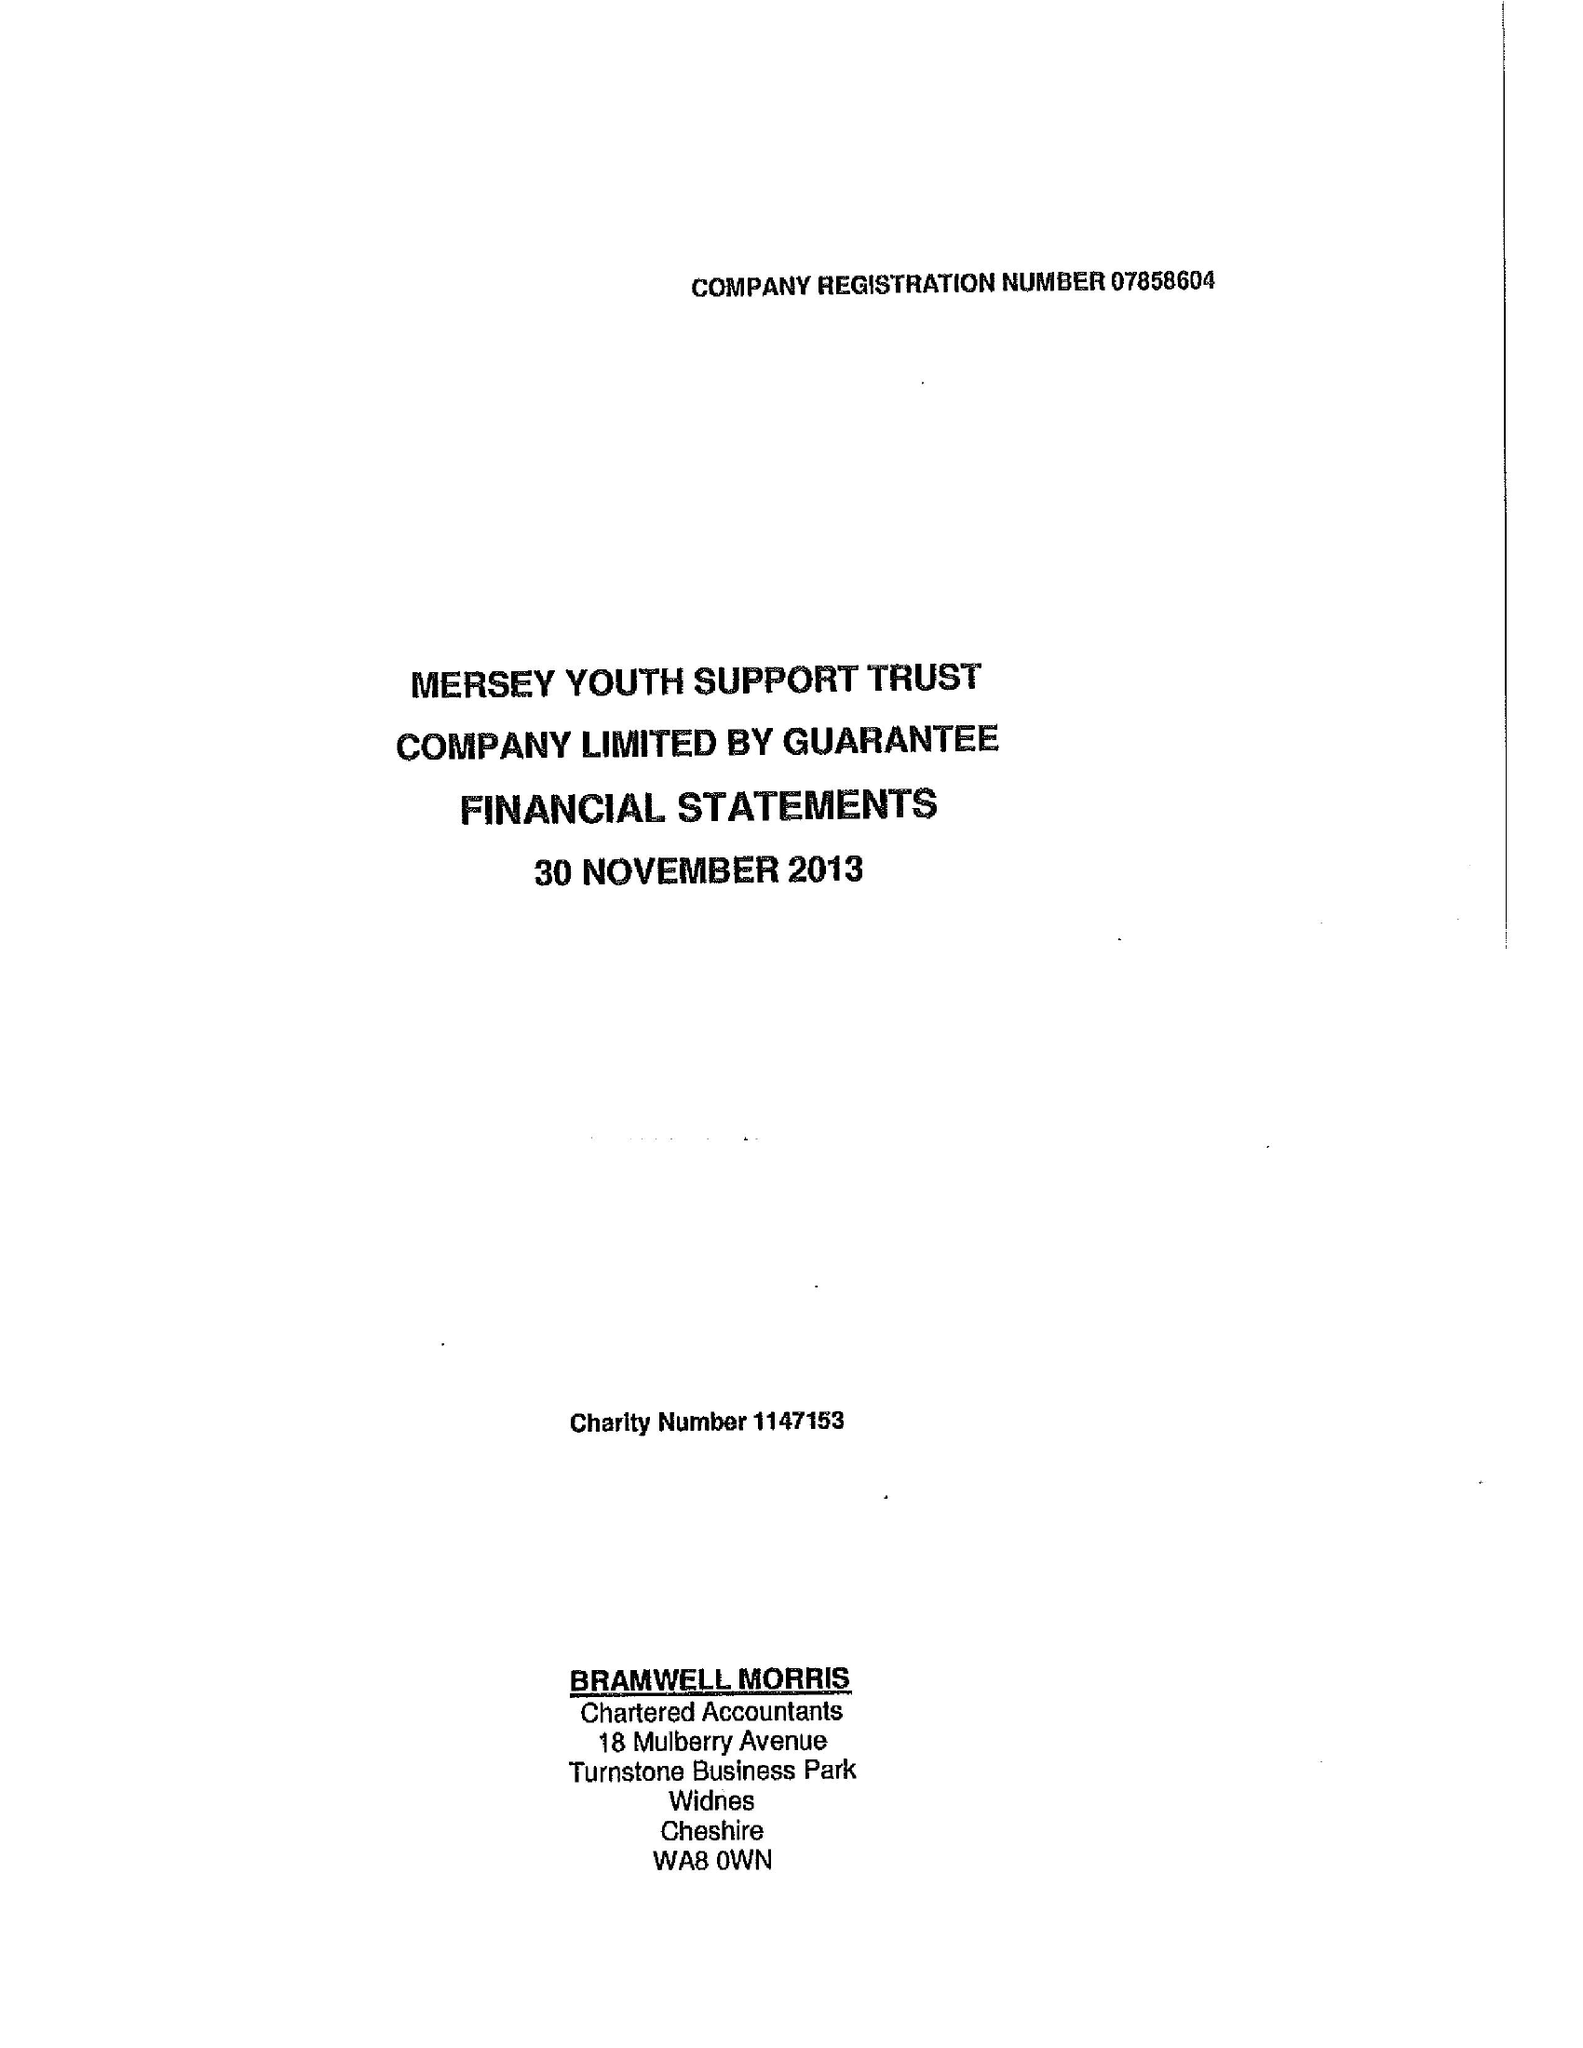What is the value for the address__street_line?
Answer the question using a single word or phrase. WESTMINSTER ROAD 